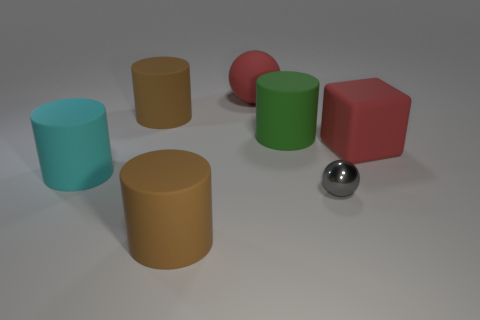Are there any rubber objects of the same color as the cube?
Your answer should be very brief. Yes. Are any green things visible?
Your answer should be very brief. Yes. There is a cylinder on the right side of the red matte sphere; does it have the same size as the big cyan matte cylinder?
Give a very brief answer. Yes. Are there fewer big rubber balls than large cylinders?
Provide a succinct answer. Yes. What is the shape of the big green matte thing that is behind the large red matte object right of the big red thing behind the block?
Your answer should be compact. Cylinder. Is there a thing made of the same material as the red sphere?
Give a very brief answer. Yes. There is a matte object to the right of the big green matte cylinder; is its color the same as the sphere that is left of the green cylinder?
Keep it short and to the point. Yes. Are there fewer big green rubber cylinders left of the large cyan thing than tiny purple cubes?
Give a very brief answer. No. What number of objects are either large purple things or large brown matte objects that are in front of the green rubber cylinder?
Give a very brief answer. 1. There is a ball that is made of the same material as the big cube; what is its color?
Your answer should be compact. Red. 